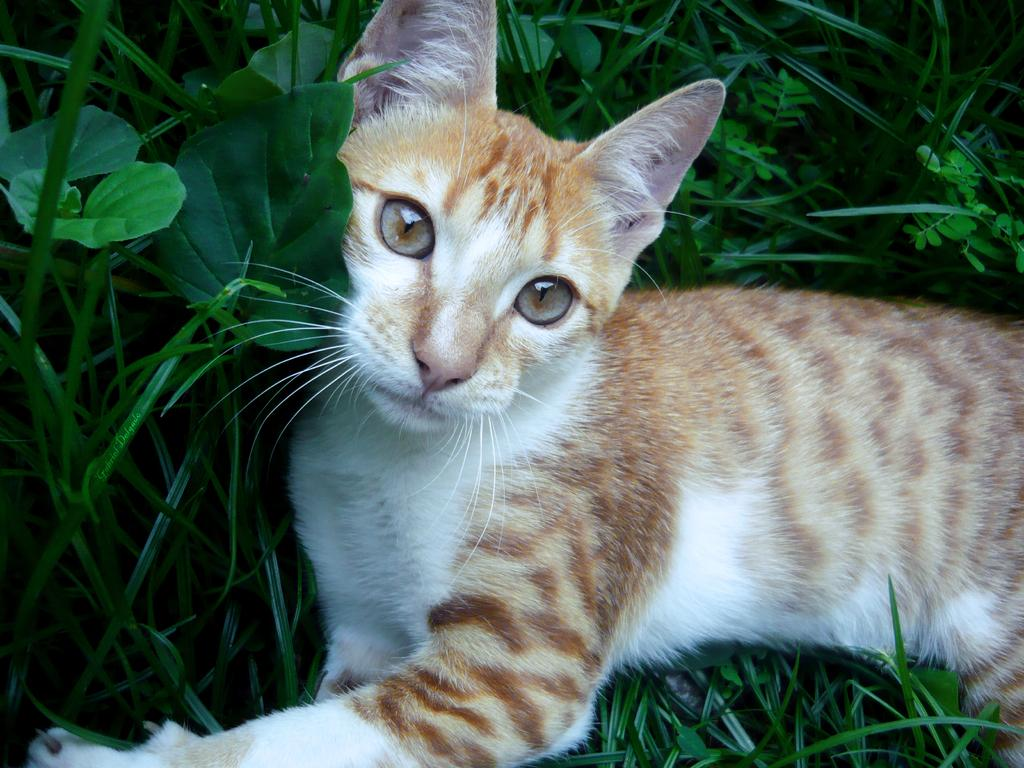What type of animal is in the image? There is a cat in the image. Can you describe the color pattern of the cat? The cat has white and brown colors. What type of vegetation is visible in the image? There is grass in the image. What color is the grass? The grass is green. Where is the baby sitting on the flame in the image? There is no baby or flame present in the image; it features a cat and green grass. What type of fowl can be seen interacting with the cat in the image? There is no fowl present in the image; only the cat and grass are visible. 